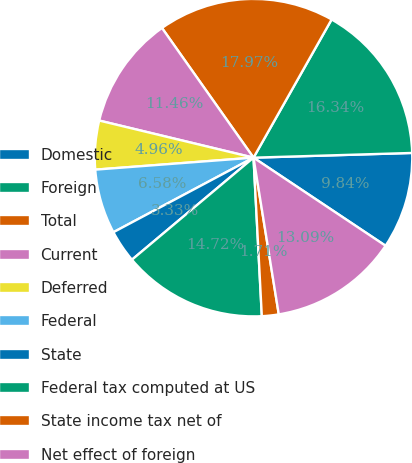Convert chart to OTSL. <chart><loc_0><loc_0><loc_500><loc_500><pie_chart><fcel>Domestic<fcel>Foreign<fcel>Total<fcel>Current<fcel>Deferred<fcel>Federal<fcel>State<fcel>Federal tax computed at US<fcel>State income tax net of<fcel>Net effect of foreign<nl><fcel>9.84%<fcel>16.34%<fcel>17.97%<fcel>11.46%<fcel>4.96%<fcel>6.58%<fcel>3.33%<fcel>14.72%<fcel>1.71%<fcel>13.09%<nl></chart> 